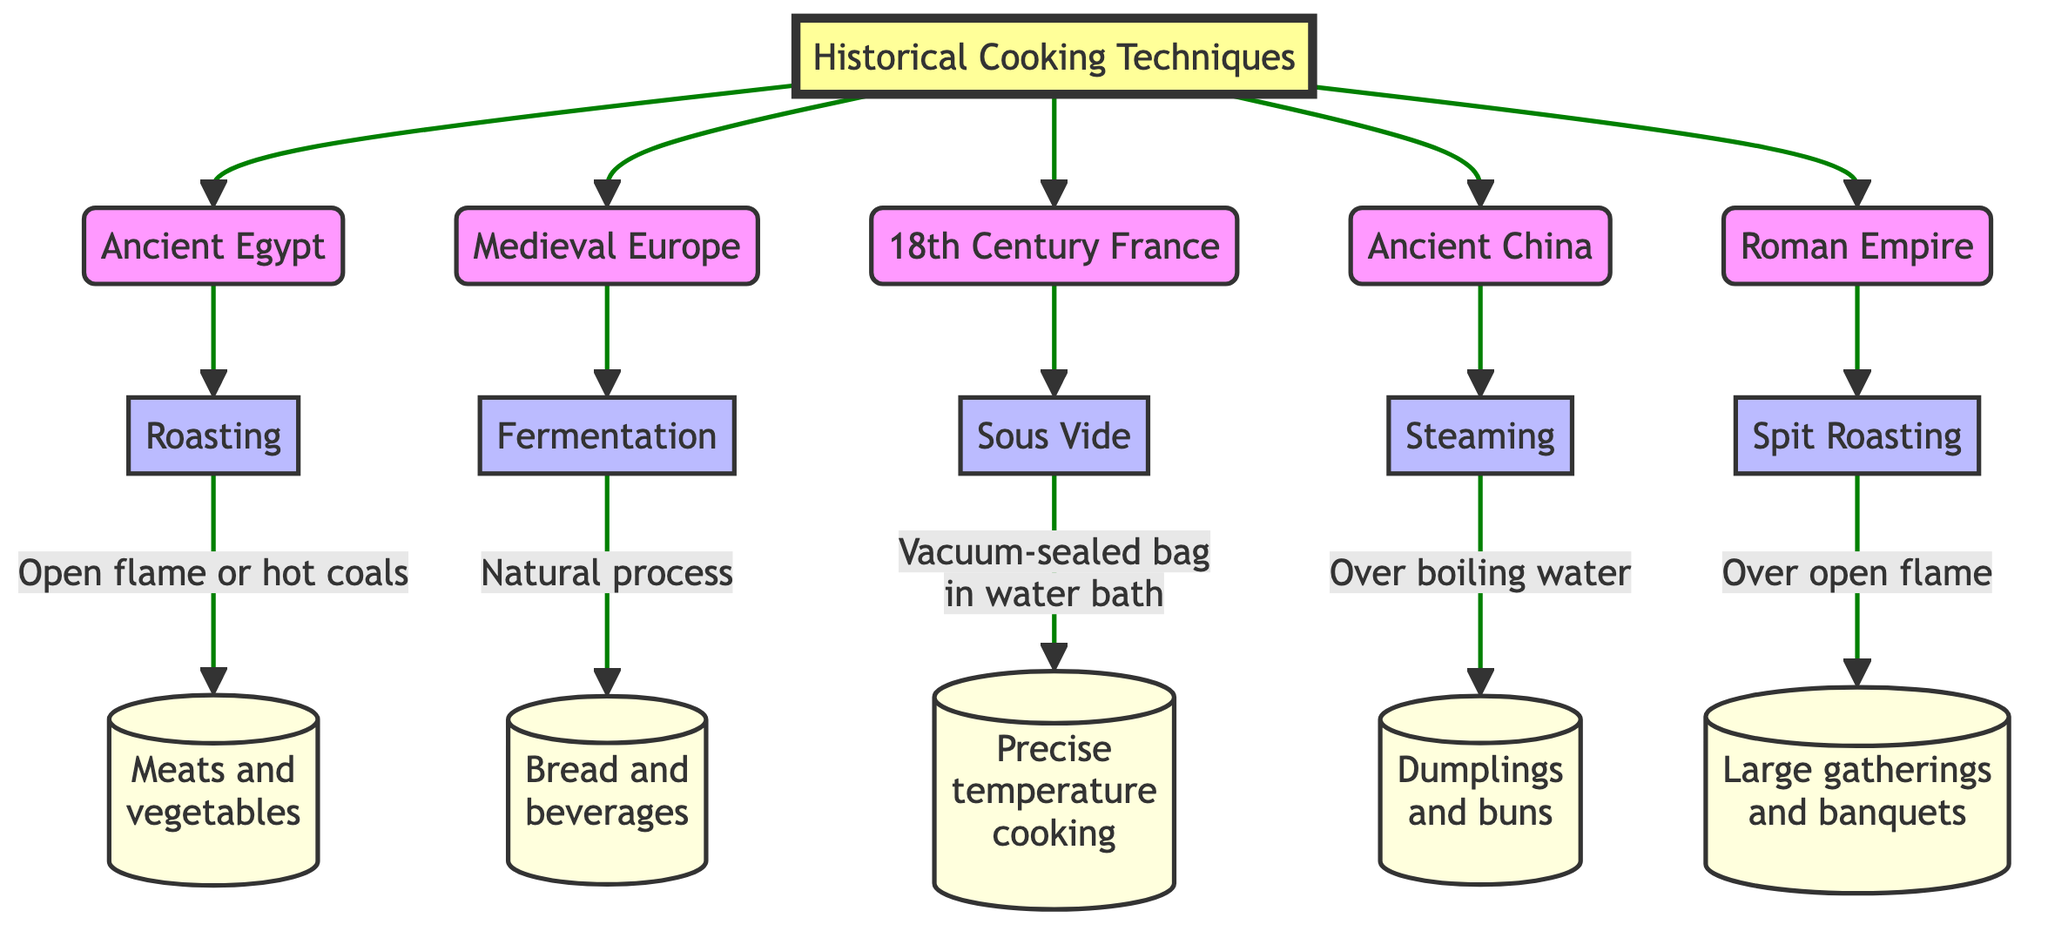What is the cooking technique associated with Ancient Egypt? The diagram shows that the node connected to Ancient Egypt is Roasting, indicating it is the technique used during that historical era.
Answer: Roasting How many historical eras are represented in the diagram? The diagram lists five distinct historical eras, each connected to a specific cooking technique. Counting the nodes leads to the answer.
Answer: 5 What is the method of cooking used in Medieval Europe? The node connected to Medieval Europe denotes the technique of Fermentation, which is specifically mentioned.
Answer: Fermentation In which historical era is Sous Vide primarily associated? The diagram directly connects the technique of Sous Vide to the node labeled 18th Century France, providing a clear relationship.
Answer: 18th Century France What food items are associated with the roasting technique? Following the connection from the Roasting node leads to the description indicating it is used for meats and vegetables, specifying the relevant food items.
Answer: Meats and vegetables Which technique employs a vacuum-sealed bag? The diagram specifies that Sous Vide uses a vacuum-sealed bag in a water bath for cooking, clearly highlighting this technique's unique method.
Answer: Sous Vide Which cooking method is used for dumplings and buns? The Steaming node in the diagram leads to the description indicating it is specifically used for cooking dumplings and buns over boiling water.
Answer: Steaming What do the edges between nodes represent in this diagram? The edges visually represent the relationships and connections between historical eras and their corresponding cooking techniques, showing the structure of the flow.
Answer: Relationships How does Spit Roasting correlate with gatherings? The diagram connects Spit Roasting with large gatherings and banquets, indicating this cooking method is associated with social occasions.
Answer: Large gatherings and banquets 